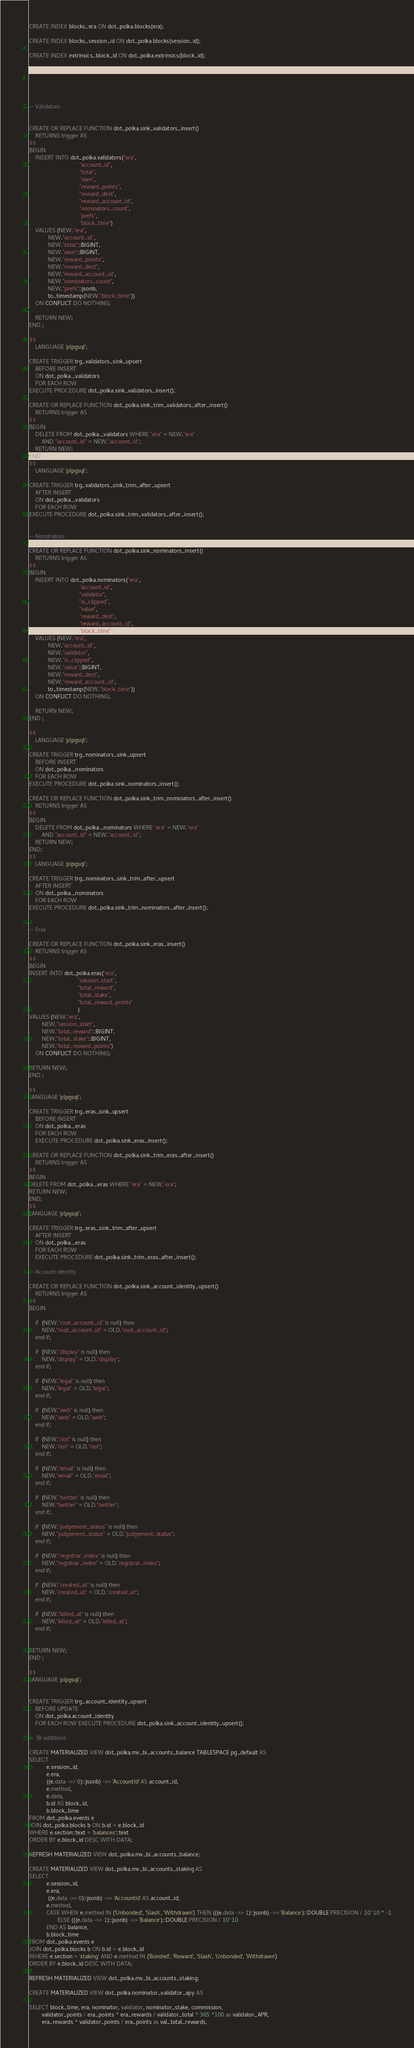Convert code to text. <code><loc_0><loc_0><loc_500><loc_500><_SQL_>CREATE INDEX blocks_era ON dot_polka.blocks(era);

CREATE INDEX blocks_session_id ON dot_polka.blocks(session_id);

CREATE INDEX extrinsics_block_id ON dot_polka.extrinsics(block_id);






-- Validators


CREATE OR REPLACE FUNCTION dot_polka.sink_validators_insert()
    RETURNS trigger AS
$$
BEGIN
    INSERT INTO dot_polka.validators("era",
                                "account_id",
                                "total",
                                "own",
                                "reward_points",
                                "reward_dest",
                                "reward_account_id",
                                "nominators_count",
                                "prefs",
                                "block_time")
    VALUES (NEW."era",
            NEW."account_id",
            NEW."total"::BIGINT,
            NEW."own"::BIGINT,
            NEW."reward_points",
            NEW."reward_dest",
            NEW."reward_account_id",
            NEW."nominators_count",
            NEW."prefs"::jsonb,
            to_timestamp(NEW."block_time"))
    ON CONFLICT DO NOTHING;

    RETURN NEW;
END ;

$$
    LANGUAGE 'plpgsql';

CREATE TRIGGER trg_validators_sink_upsert
    BEFORE INSERT
    ON dot_polka._validators
    FOR EACH ROW
EXECUTE PROCEDURE dot_polka.sink_validators_insert();

CREATE OR REPLACE FUNCTION dot_polka.sink_trim_validators_after_insert()
    RETURNS trigger AS
$$
BEGIN
    DELETE FROM dot_polka._validators WHERE "era" = NEW."era"
        AND "account_id" = NEW."account_id";
    RETURN NEW;
END;
$$
    LANGUAGE 'plpgsql';

CREATE TRIGGER trg_validators_sink_trim_after_upsert
    AFTER INSERT
    ON dot_polka._validators
    FOR EACH ROW
EXECUTE PROCEDURE dot_polka.sink_trim_validators_after_insert();


-- Nominators

CREATE OR REPLACE FUNCTION dot_polka.sink_nominators_insert()
    RETURNS trigger AS
$$
BEGIN
    INSERT INTO dot_polka.nominators("era",
                                "account_id",
                                "validator",
                                "is_clipped",
                                "value",
                                "reward_dest",
                                "reward_account_id",
                                "block_time")
    VALUES (NEW."era",
            NEW."account_id",
            NEW."validator",
            NEW."is_clipped",
            NEW."value"::BIGINT,
            NEW."reward_dest",
            NEW."reward_account_id",
            to_timestamp(NEW."block_time"))
    ON CONFLICT DO NOTHING;

    RETURN NEW;
END ;

$$
    LANGUAGE 'plpgsql';

CREATE TRIGGER trg_nominators_sink_upsert
    BEFORE INSERT
    ON dot_polka._nominators
    FOR EACH ROW
EXECUTE PROCEDURE dot_polka.sink_nominators_insert();

CREATE OR REPLACE FUNCTION dot_polka.sink_trim_nominators_after_insert()
    RETURNS trigger AS
$$
BEGIN
    DELETE FROM dot_polka._nominators WHERE "era" = NEW."era"
        AND "account_id" = NEW."account_id";
    RETURN NEW;
END;
$$
    LANGUAGE 'plpgsql';

CREATE TRIGGER trg_nominators_sink_trim_after_upsert
    AFTER INSERT
    ON dot_polka._nominators
    FOR EACH ROW
EXECUTE PROCEDURE dot_polka.sink_trim_nominators_after_insert();


-- Eras

CREATE OR REPLACE FUNCTION dot_polka.sink_eras_insert()
    RETURNS trigger AS
$$
BEGIN
INSERT INTO dot_polka.eras("era",
                               "session_start",
                               "total_reward",
                               "total_stake",
                               "total_reward_points"
                               )
VALUES (NEW."era",
        NEW."session_start",
        NEW."total_reward"::BIGINT,
        NEW."total_stake"::BIGINT,
        NEW."total_reward_points")
    ON CONFLICT DO NOTHING;

RETURN NEW;
END ;

$$
LANGUAGE 'plpgsql';

CREATE TRIGGER trg_eras_sink_upsert
    BEFORE INSERT
    ON dot_polka._eras
    FOR EACH ROW
    EXECUTE PROCEDURE dot_polka.sink_eras_insert();

CREATE OR REPLACE FUNCTION dot_polka.sink_trim_eras_after_insert()
    RETURNS trigger AS
$$
BEGIN
DELETE FROM dot_polka._eras WHERE "era" = NEW."era";
RETURN NEW;
END;
$$
LANGUAGE 'plpgsql';

CREATE TRIGGER trg_eras_sink_trim_after_upsert
    AFTER INSERT
    ON dot_polka._eras
    FOR EACH ROW
    EXECUTE PROCEDURE dot_polka.sink_trim_eras_after_insert();

-- Account identity

CREATE OR REPLACE FUNCTION dot_polka.sink_account_identity_upsert()
    RETURNS trigger AS
$$
BEGIN

    if  (NEW."root_account_id" is null) then
		NEW."root_account_id" = OLD."root_account_id";
	end if;

    if  (NEW."display" is null) then
		NEW."display" = OLD."display";
	end if;

    if  (NEW."legal" is null) then
		NEW."legal" = OLD."legal";
	end if;

    if  (NEW."web" is null) then
		NEW."web" = OLD."web";
	end if;

    if  (NEW."riot" is null) then
		NEW."riot" = OLD."riot";
	end if;

    if  (NEW."email" is null) then
		NEW."email" = OLD."email";
	end if;

    if  (NEW."twitter" is null) then
		NEW."twitter" = OLD."twitter";
	end if;

    if  (NEW."judgement_status" is null) then
		NEW."judgement_status" = OLD."judgement_status";
	end if;

    if  (NEW."registrar_index" is null) then
		NEW."registrar_index" = OLD."registrar_index";
	end if;

    if  (NEW."created_at" is null) then
		NEW."created_at" = OLD."created_at";
	end if;

    if  (NEW."killed_at" is null) then
		NEW."killed_at" = OLD."killed_at";
	end if;


RETURN NEW;
END ;

$$
LANGUAGE 'plpgsql';


CREATE TRIGGER trg_account_identity_upsert
    BEFORE UPDATE
    ON dot_polka.account_identity
    FOR EACH ROW EXECUTE PROCEDURE dot_polka.sink_account_identity_upsert();

--  BI additions

CREATE MATERIALIZED VIEW dot_polka.mv_bi_accounts_balance TABLESPACE pg_default AS
SELECT
           e.session_id,
           e.era,
           ((e.data ->> 0)::jsonb) ->> 'AccountId' AS account_id,
           e.method,
           e.data,
           b.id AS block_id,
           b.block_time
FROM dot_polka.events e
JOIN dot_polka.blocks b ON b.id = e.block_id
WHERE e.section::text = 'balances'::text
ORDER BY e.block_id DESC WITH DATA;

REFRESH MATERIALIZED VIEW dot_polka.mv_bi_accounts_balance;

CREATE MATERIALIZED VIEW dot_polka.mv_bi_accounts_staking AS
SELECT
           e.session_id,
           e.era,
            ((e.data ->> 0)::jsonb) ->> 'AccountId' AS account_id,
           e.method,
           CASE WHEN e.method IN ('Unbonded', 'Slash', 'Withdrawn') THEN (((e.data ->> 1)::jsonb) ->> 'Balance')::DOUBLE PRECISION / 10^10 * -1
                  ELSE (((e.data ->> 1)::jsonb) ->> 'Balance')::DOUBLE PRECISION / 10^10
           END AS balance,
           b.block_time
FROM dot_polka.events e
JOIN dot_polka.blocks b ON b.id = e.block_id
WHERE e.section = 'staking' AND e.method IN ('Bonded', 'Reward', 'Slash', 'Unbonded', 'Withdrawn')
ORDER BY e.block_id DESC WITH DATA;

REFRESH MATERIALIZED VIEW dot_polka.mv_bi_accounts_staking;

CREATE MATERIALIZED VIEW dot_polka.nominator_validator_apy AS 

SELECT block_time, era, nominator, validator, nominator_stake, commission,
        validator_points / era_points * era_rewards / validator_total * 365 *100 as validator_APR,
        era_rewards * validator_points / era_points as val_total_rewards,</code> 